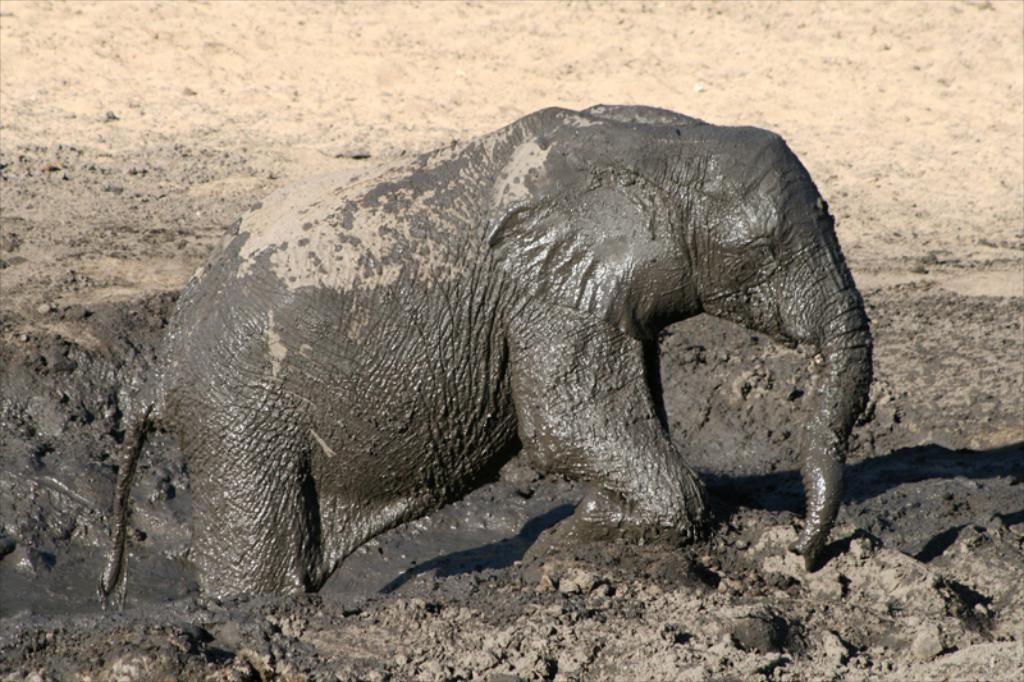What animal is present in the image? There is an elephant in the image. What is the elephant's current state or activity? The elephant appears to be coming out of the mud. Where is this scene located in the image? This scene is in the foreground of the image. How many eggs are visible in the image? There are no eggs present in the image. What type of secretary can be seen working in the image? There is no secretary present in the image. Is there any smoke visible in the image? There is no smoke present in the image. 